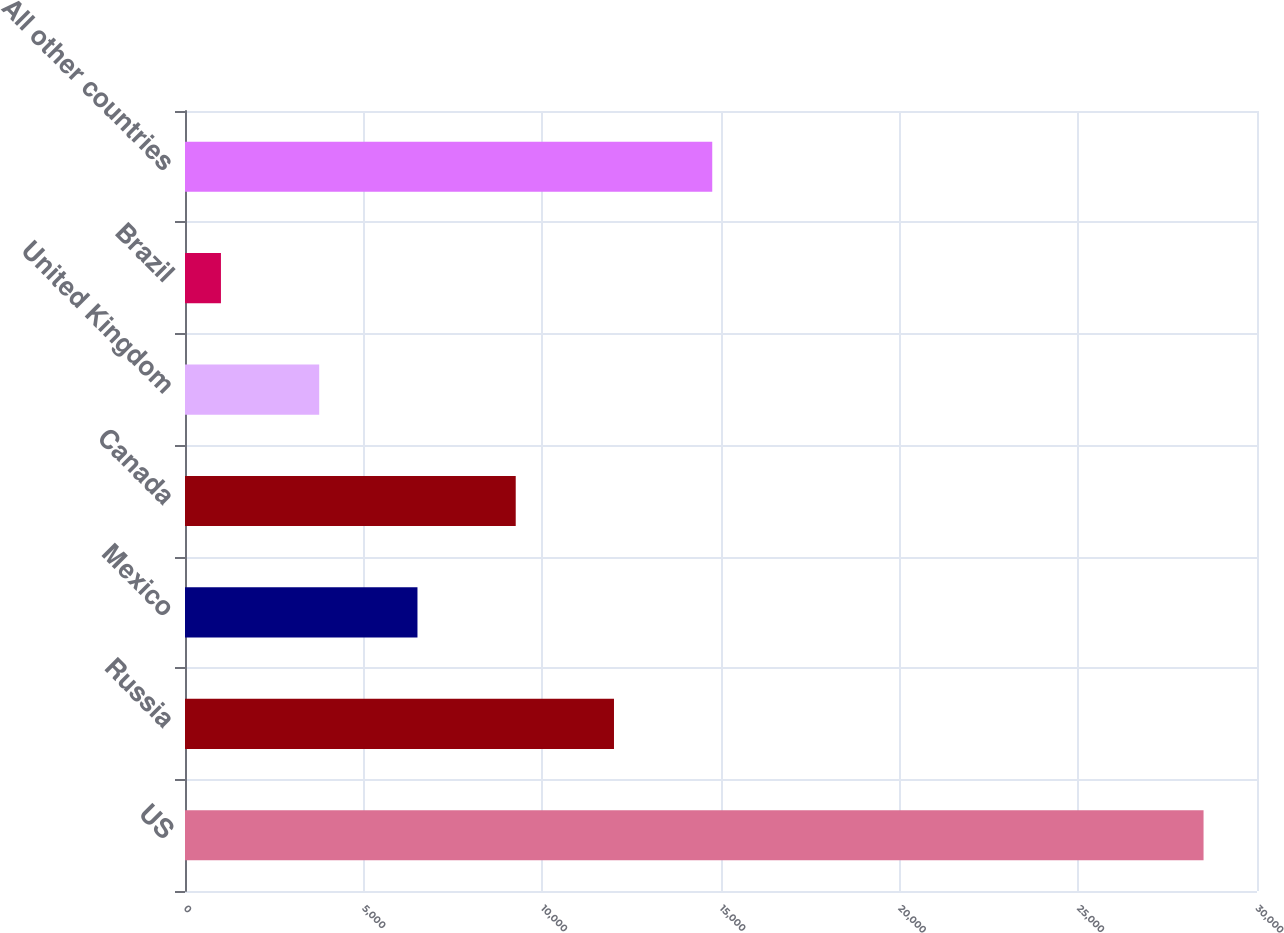Convert chart to OTSL. <chart><loc_0><loc_0><loc_500><loc_500><bar_chart><fcel>US<fcel>Russia<fcel>Mexico<fcel>Canada<fcel>United Kingdom<fcel>Brazil<fcel>All other countries<nl><fcel>28504<fcel>12005.2<fcel>6505.6<fcel>9255.4<fcel>3755.8<fcel>1006<fcel>14755<nl></chart> 